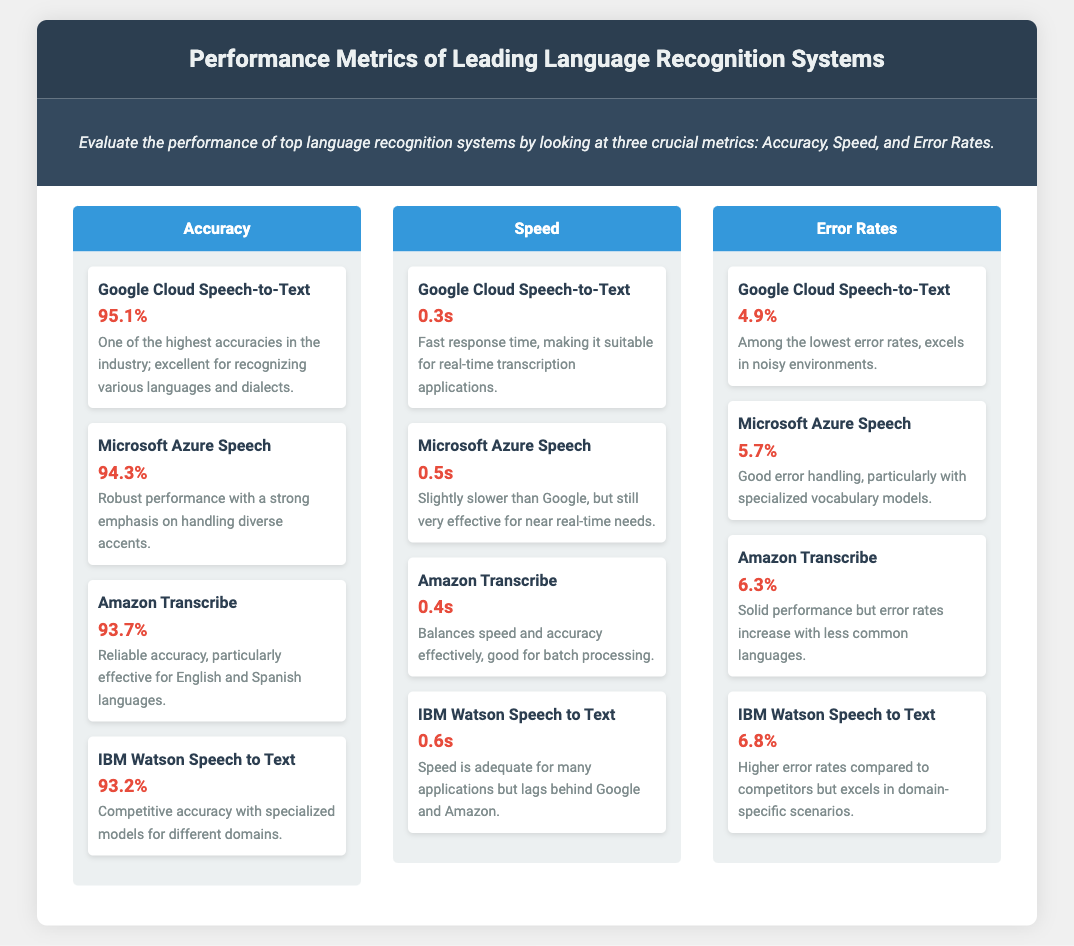what is the highest accuracy achieved by a language recognition system? The highest accuracy is listed under Google Cloud Speech-to-Text, which is 95.1%.
Answer: 95.1% which system has the fastest speed? The fastest speed is attributed to Google Cloud Speech-to-Text, with a response time of 0.3 seconds.
Answer: 0.3s what is the error rate for Amazon Transcribe? The error rate for Amazon Transcribe is stated as 6.3%.
Answer: 6.3% which language recognition system has the lowest accuracy? The system with the lowest accuracy is IBM Watson Speech to Text, which has an accuracy of 93.2%.
Answer: 93.2% how does Microsoft Azure Speech's error rate compare to Google Cloud Speech-to-Text? Microsoft Azure Speech has an error rate of 5.7%, while Google Cloud Speech-to-Text has a lower error rate of 4.9%.
Answer: Higher what speed does IBM Watson Speech to Text operate at? IBM Watson Speech to Text operates at a speed of 0.6 seconds.
Answer: 0.6s which system is best for real-time transcription applications? Google Cloud Speech-to-Text is indicated as suitable for real-time transcription applications due to its fast response time.
Answer: Google Cloud Speech-to-Text what metric indicates the performance of language recognition systems on noisy environments? The document discusses error rates, particularly noting that Google Cloud Speech-to-Text excels in noisy environments with the lowest rate.
Answer: Error Rates which system has a strong emphasis on handling diverse accents? Microsoft Azure Speech is noted for its robust performance with a strong emphasis on handling diverse accents.
Answer: Microsoft Azure Speech 